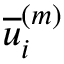Convert formula to latex. <formula><loc_0><loc_0><loc_500><loc_500>\overline { u } _ { i } ^ { \left ( m \right ) }</formula> 